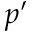Convert formula to latex. <formula><loc_0><loc_0><loc_500><loc_500>p ^ { \prime }</formula> 